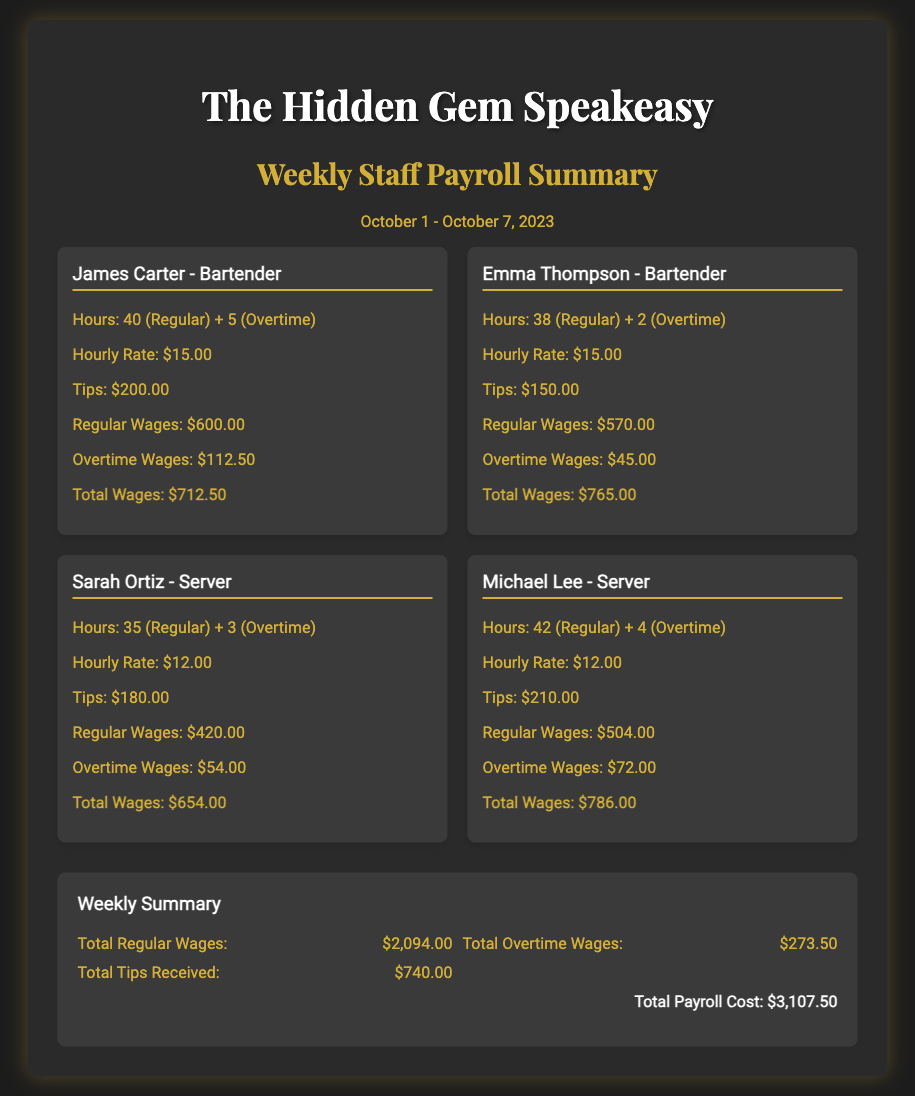what is the total payroll cost? The total payroll cost is clearly stated at the bottom of the summary section, which is $3,107.50.
Answer: $3,107.50 who is the server with the highest total wages? Michael Lee has the highest total wages of $786.00 among the staff listed.
Answer: Michael Lee how many hours did Sarah Ortiz work in total? Sarah Ortiz worked a total of 38 regular hours and 3 overtime hours, making it 41 hours.
Answer: 41 what is the hourly rate for bartenders? The hourly rate for bartenders, as indicated for both James Carter and Emma Thompson, is $15.00.
Answer: $15.00 how much did Emma Thompson earn in tips? Emma Thompson's tips are listed as $150.00 in her staff card.
Answer: $150.00 what is the total amount of tips received by all staff? The total tips received are calculated from all individual tips, which sum up to $740.00 in the summary.
Answer: $740.00 how much did James Carter earn in overtime wages? James Carter's overtime wages are specified as $112.50 on his card.
Answer: $112.50 what percentage of the total payroll cost is made up of total tips received? The percentage can be calculated by dividing total tips by total payroll cost, which is $\frac{740.00}{3107.50} \approx 23.8\%.
Answer: 23.8% 